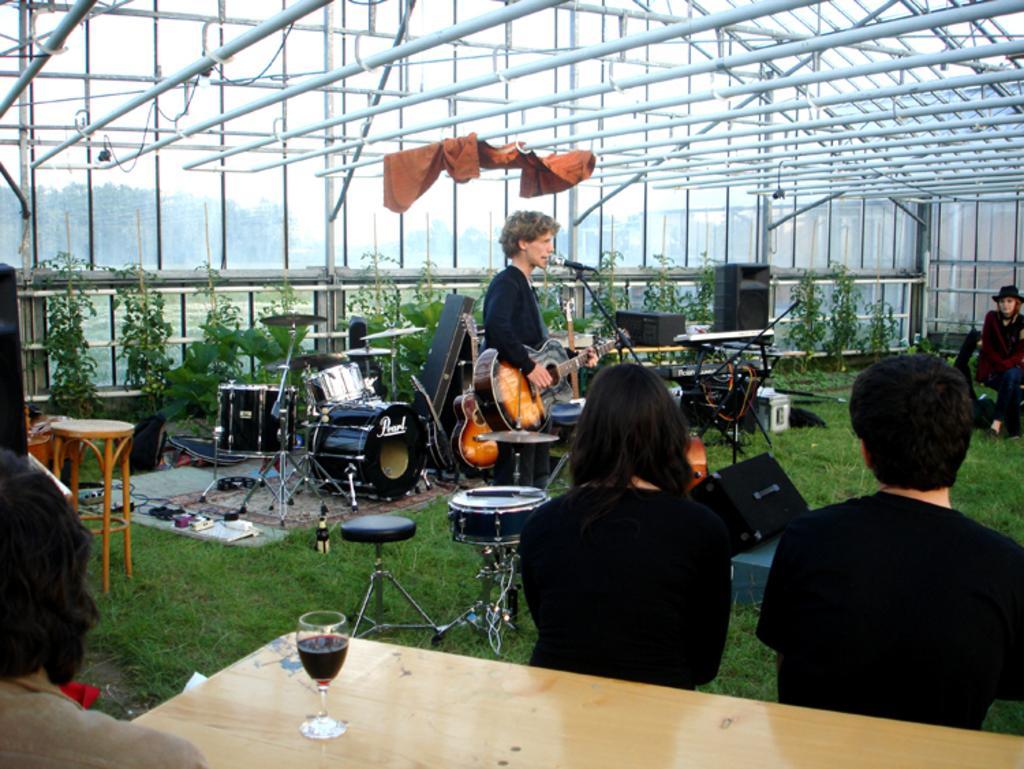Could you give a brief overview of what you see in this image? This are rods. This person is holding a guitar and singing in-front of a mic. This persons are sitting on a chair. This are musical instruments. This are plants. This is grass in green color. On a table there is a glass. 